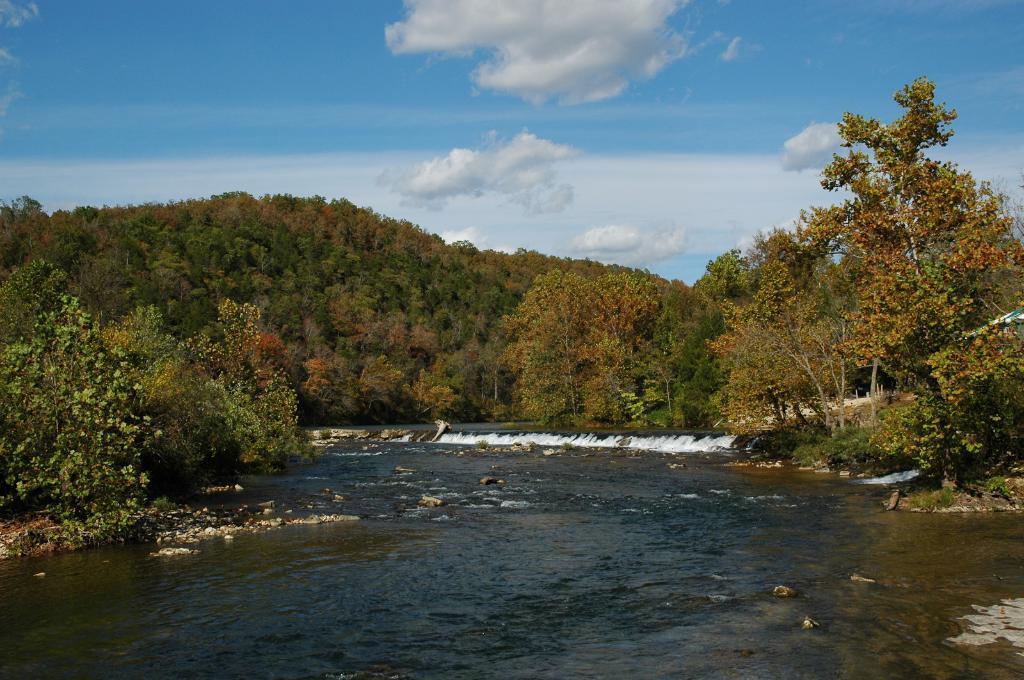How would you summarize this image in a sentence or two? In this image in the front there is water. In the background there are trees and the sky is cloudy. 